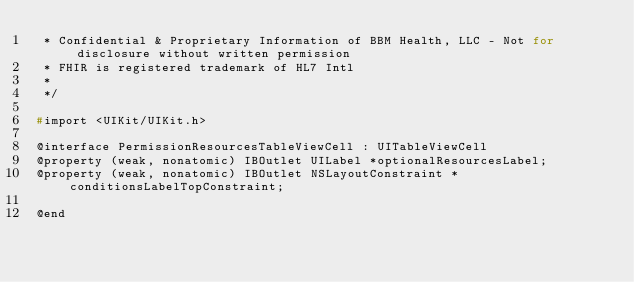Convert code to text. <code><loc_0><loc_0><loc_500><loc_500><_C_> * Confidential & Proprietary Information of BBM Health, LLC - Not for disclosure without written permission
 * FHIR is registered trademark of HL7 Intl
 *
 */

#import <UIKit/UIKit.h>

@interface PermissionResourcesTableViewCell : UITableViewCell
@property (weak, nonatomic) IBOutlet UILabel *optionalResourcesLabel;
@property (weak, nonatomic) IBOutlet NSLayoutConstraint *conditionsLabelTopConstraint;

@end
</code> 